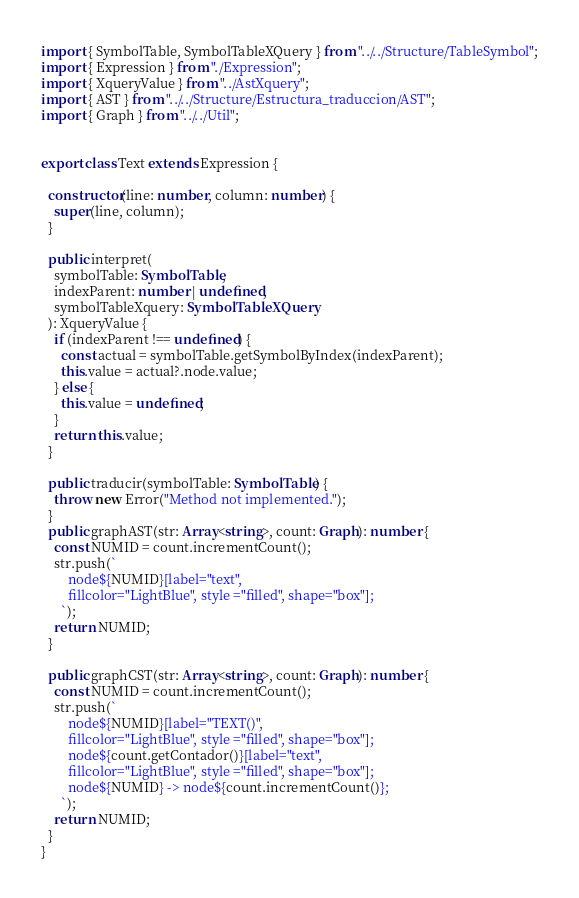Convert code to text. <code><loc_0><loc_0><loc_500><loc_500><_TypeScript_>import { SymbolTable, SymbolTableXQuery } from "../../Structure/TableSymbol";
import { Expression } from "./Expression";
import { XqueryValue } from "../AstXquery";
import { AST } from "../../Structure/Estructura_traduccion/AST";
import { Graph } from "../../Util";


export class Text extends Expression {

  constructor(line: number, column: number) {
    super(line, column);
  }

  public interpret(
    symbolTable: SymbolTable,
    indexParent: number | undefined,
    symbolTableXquery: SymbolTableXQuery
  ): XqueryValue {
    if (indexParent !== undefined) {
      const actual = symbolTable.getSymbolByIndex(indexParent);
      this.value = actual?.node.value;
    } else {
      this.value = undefined;
    }
    return this.value;
  }

  public traducir(symbolTable: SymbolTable) {
    throw new Error("Method not implemented.");
  }
  public graphAST(str: Array<string>, count: Graph): number {
    const NUMID = count.incrementCount();
    str.push(`
        node${NUMID}[label="text",
        fillcolor="LightBlue", style ="filled", shape="box"];
      `);
    return NUMID;
  }

  public graphCST(str: Array<string>, count: Graph): number {
    const NUMID = count.incrementCount();
    str.push(`
        node${NUMID}[label="TEXT()",
        fillcolor="LightBlue", style ="filled", shape="box"];
        node${count.getContador()}[label="text",
        fillcolor="LightBlue", style ="filled", shape="box"];
        node${NUMID} -> node${count.incrementCount()};
      `);
    return NUMID;
  }
}
</code> 